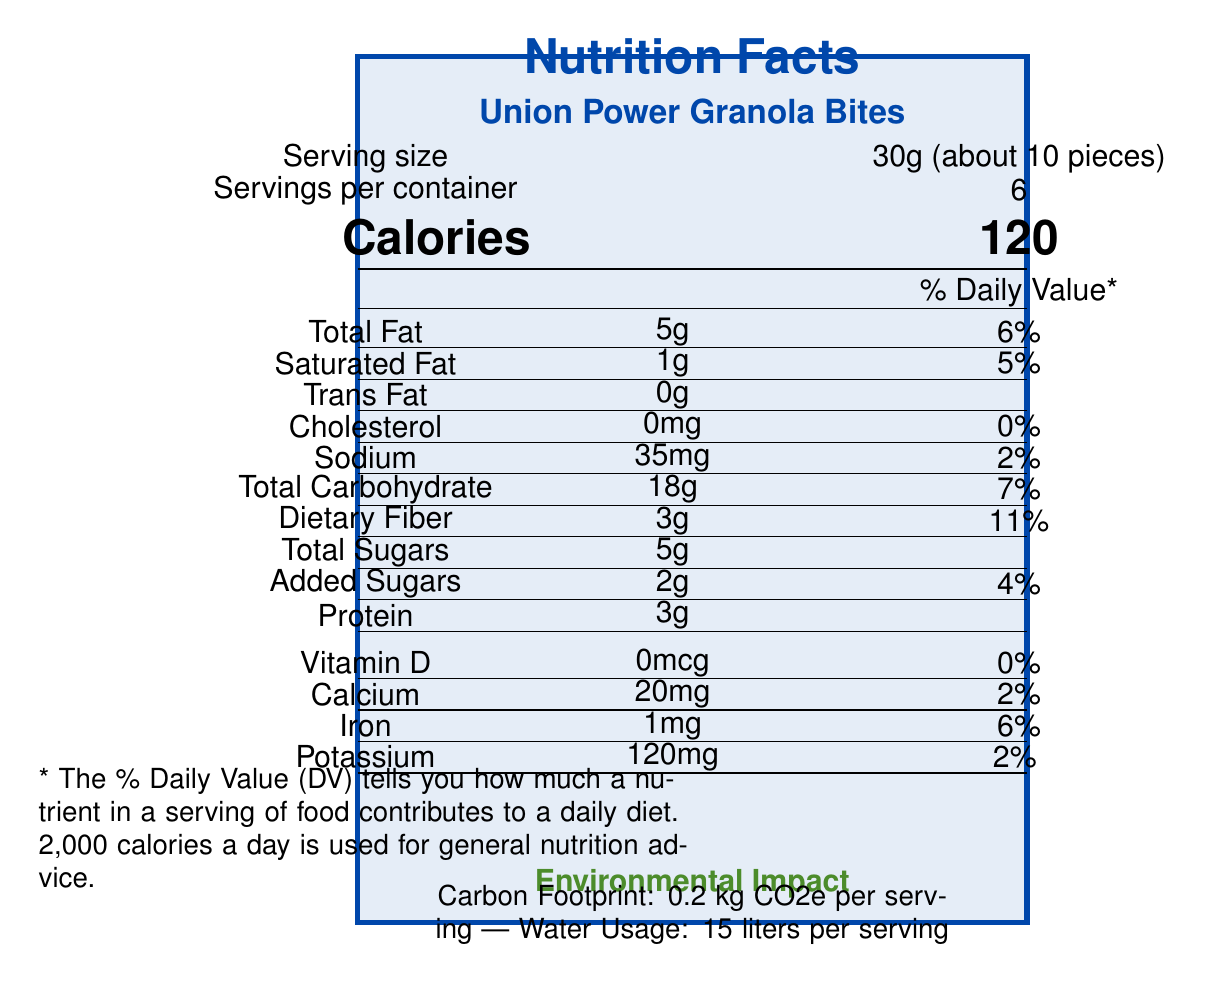what is the serving size? The serving size is clearly listed next to the "Serving size" label on the document as "30g (about 10 pieces)".
Answer: 30g (about 10 pieces) how many calories are in one serving? The calorie count per serving is prominently displayed next to the "Calories" label as "120".
Answer: 120 calories how much fiber is in one serving? The amount of dietary fiber is listed under "Dietary Fiber" in the nutrient table as "3g".
Answer: 3g what is the added sugar content per serving? The added sugar content is specified in the line "Added Sugars" as "2g".
Answer: 2g what are the ingredients of Union Power Granola Bites? The ingredients list is provided in the document and includes these eight items.
Answer: Organic rolled oats, Organic almonds, Organic sunflower seeds, Organic dried cranberries, Organic honey, Organic coconut oil, Organic cinnamon, Sea salt how much sodium does each serving contain? The sodium content per serving is listed under "Sodium" as "35mg".
Answer: 35mg how much iron is in one serving? A. 1mg B. 2mg C. 3mg D. 4mg The iron content per serving is mentioned under "Iron" as "1mg".
Answer: A. 1mg which nutrient has the highest % Daily Value in one serving? A. Vitamin D B. Total Fat C. Fiber D. Protein The nutrient with the highest % Daily Value is Dietary Fiber, with a Daily Value percentage of 11%.
Answer: C. Fiber does the product contain any genetically modified organisms (GMOs)? The product has a "Non-GMO Project Verified" certification indicating it does not contain GMOs.
Answer: No describe the environmental impact of Union Power Granola Bites. The environmental impact section details the carbon footprint, water usage, and packaging information.
Answer: The carbon footprint is 0.2 kg CO2e per serving, water usage is 15 liters per serving, and the packaging is 100% compostable, made from plant-based materials. what is the total amount of calories in the entire container? Since the container has 6 servings and each serving has 120 calories, the total calories are 120 * 6 = 720.
Answer: 720 calories where are the oats in the product sourced from? The sourcing information for the oats indicates they are harvested from Blue River Organic Farm, located 20 miles from the production facility.
Answer: Blue River Organic Farm, 20 miles from the production facility what is the minimum wage of production workers? The document states that production workers earn a minimum wage of $18 per hour.
Answer: $18 per hour are the production workers represented by a specific union? The production workers are unionized and represented by United Food and Commercial Workers (UFCW).
Answer: Yes, United Food and Commercial Workers (UFCW) how much vitamin D is in one serving? The amount of vitamin D per serving is listed as "0mcg".
Answer: 0mcg is the packaging of the product recyclable? The packaging is 100% compostable, which is a different property from being recyclable.
Answer: No how is the product described on the label regarding its support for labor? The rally message describes the product's support for workers' rights, local sourcing, environmental friendliness, and unionized production.
Answer: "Fuel your fight for workers' rights with Union Power Granola Bites – locally sourced, environmentally friendly, and made by proud union members!" what company produces Union Power Granola Bites? The document does not provide the name of the company that produces Union Power Granola Bites.
Answer: Not stated Which certification(s) does the product have? (Select all that apply) A. USDA Organic B. Non-GMO Project Verified C. Fair Trade Certified D. All of the above The document lists the following certifications: USDA Organic, Non-GMO Project Verified, Fair Trade Certified, and B Corp Certified.
Answer: D. All of the above describe the main idea of the document. The main idea encompasses various aspects of Union Power Granola Bites including its nutritional value, production ethics, environmental impact, and message for labor rallies.
Answer: The document provides detailed nutrition facts, ingredient information, environmental impact, sourcing details, labor practices, and certifications for Union Power Granola Bites. It highlights the product's support for worker's rights, local sourcing, and its environmental friendliness. 